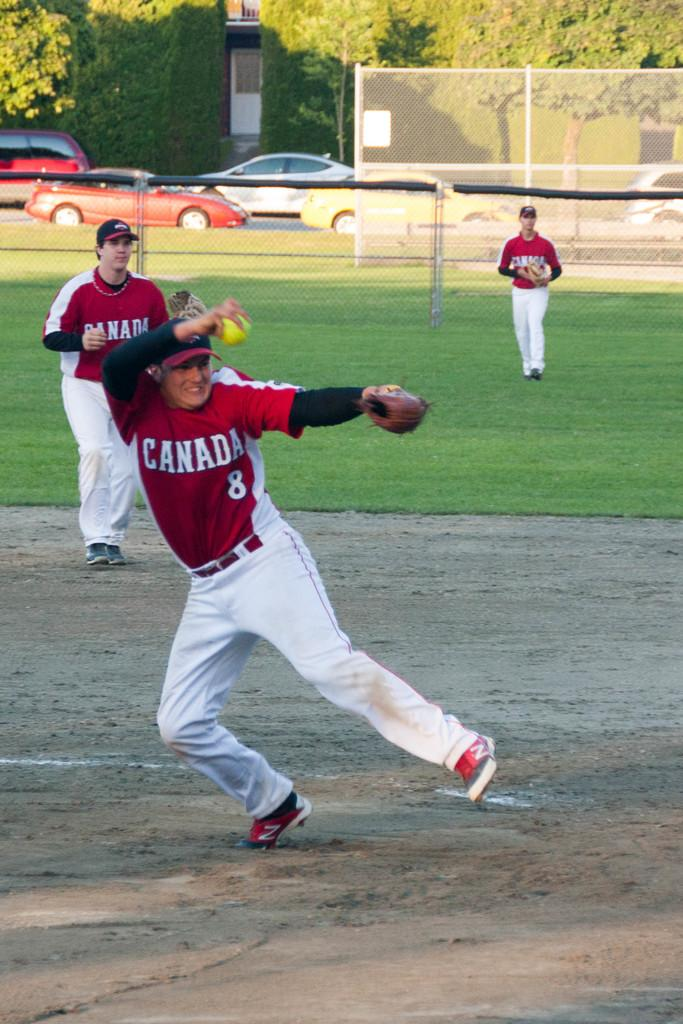<image>
Share a concise interpretation of the image provided. a player from Canada that is going after the ball 